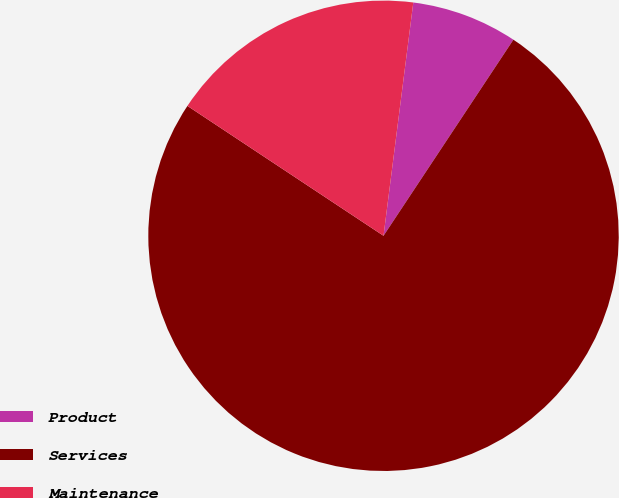Convert chart. <chart><loc_0><loc_0><loc_500><loc_500><pie_chart><fcel>Product<fcel>Services<fcel>Maintenance<nl><fcel>7.29%<fcel>75.0%<fcel>17.71%<nl></chart> 